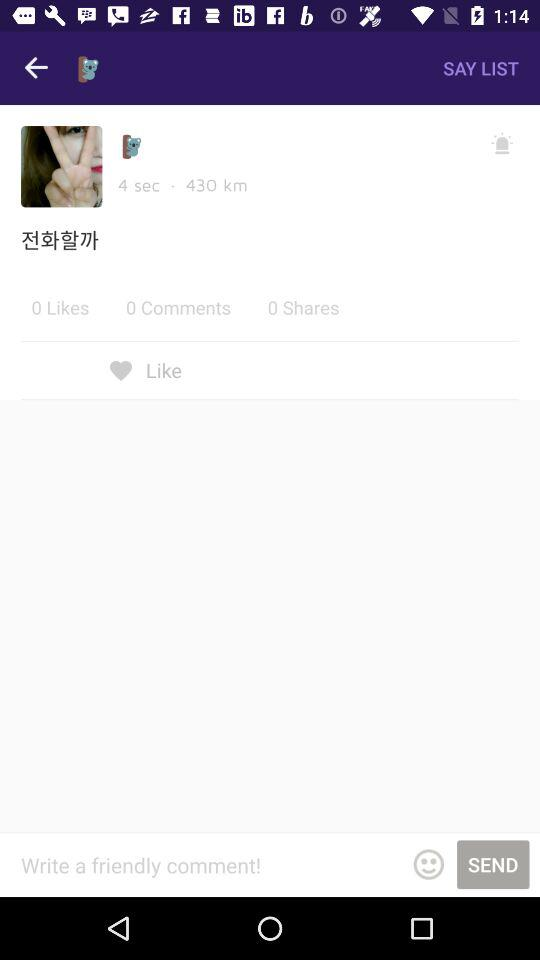What is the username?
When the provided information is insufficient, respond with <no answer>. <no answer> 